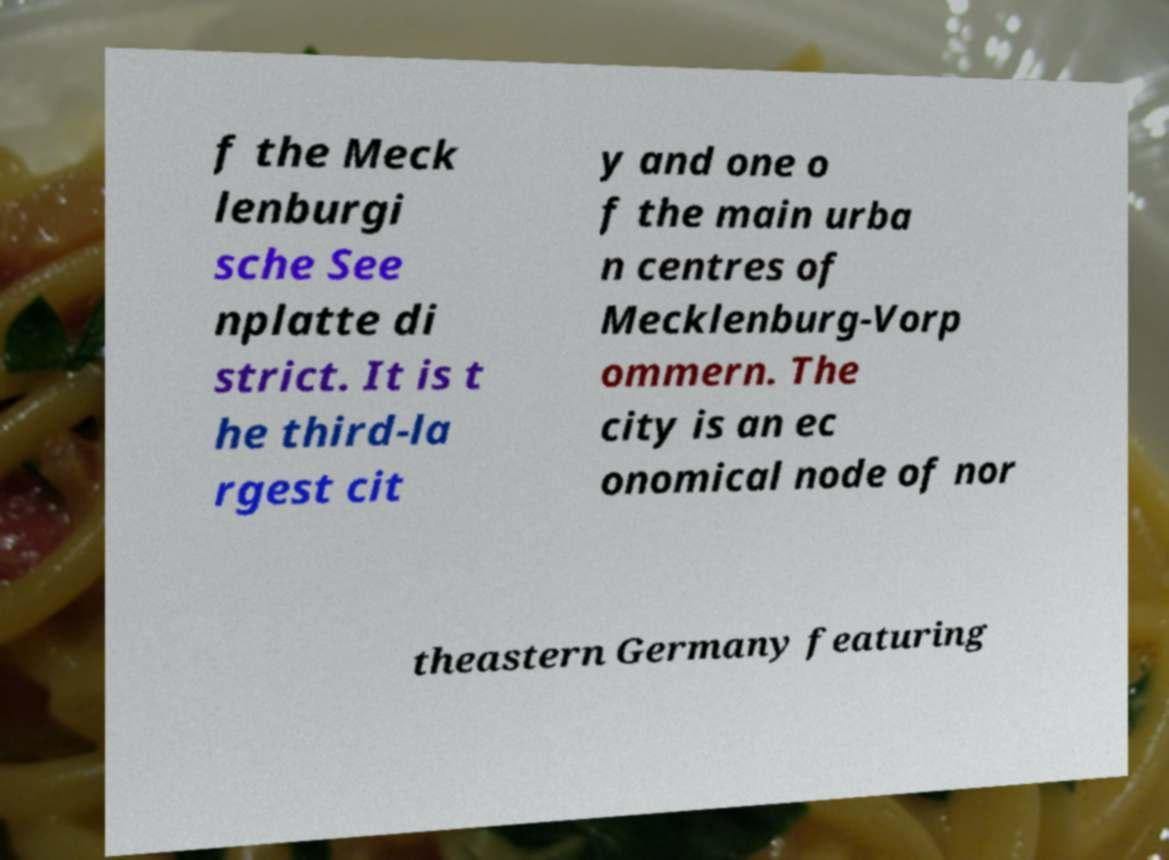There's text embedded in this image that I need extracted. Can you transcribe it verbatim? f the Meck lenburgi sche See nplatte di strict. It is t he third-la rgest cit y and one o f the main urba n centres of Mecklenburg-Vorp ommern. The city is an ec onomical node of nor theastern Germany featuring 